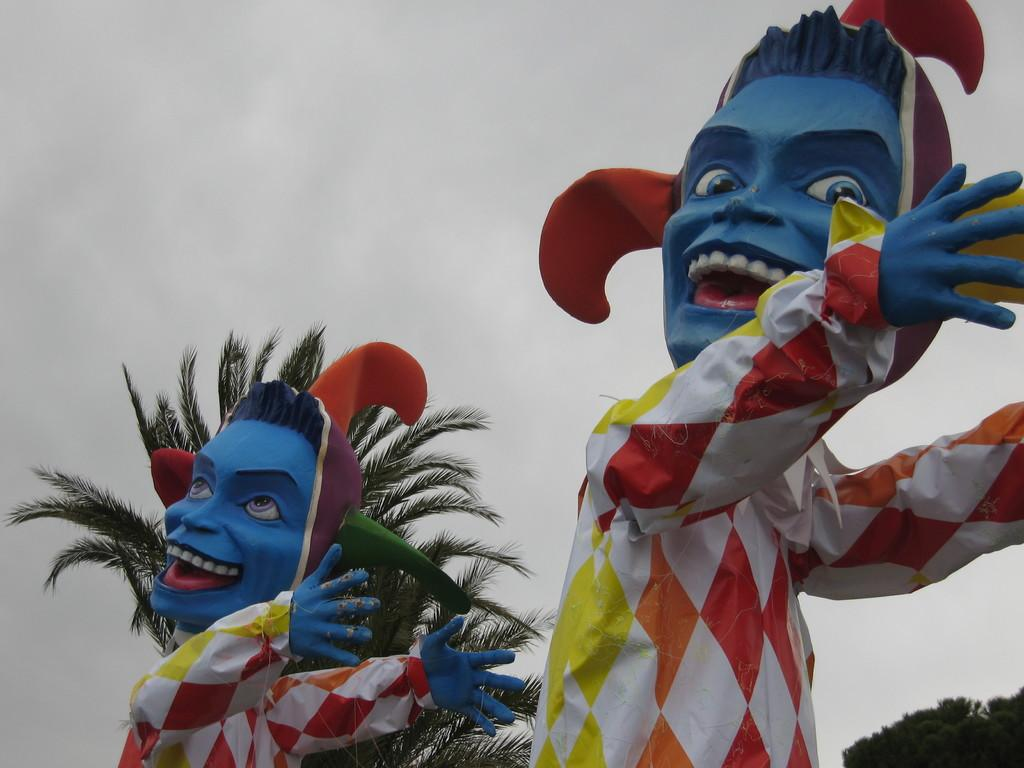What type of objects are in the image? There are two cartoon statues in the image. What can be seen in the background of the image? There are trees and a cloudy sky in the background of the image. What adjustments are being made to the office furniture in the image? There is no office furniture present in the image; it features two cartoon statues and a background with trees and a cloudy sky. 